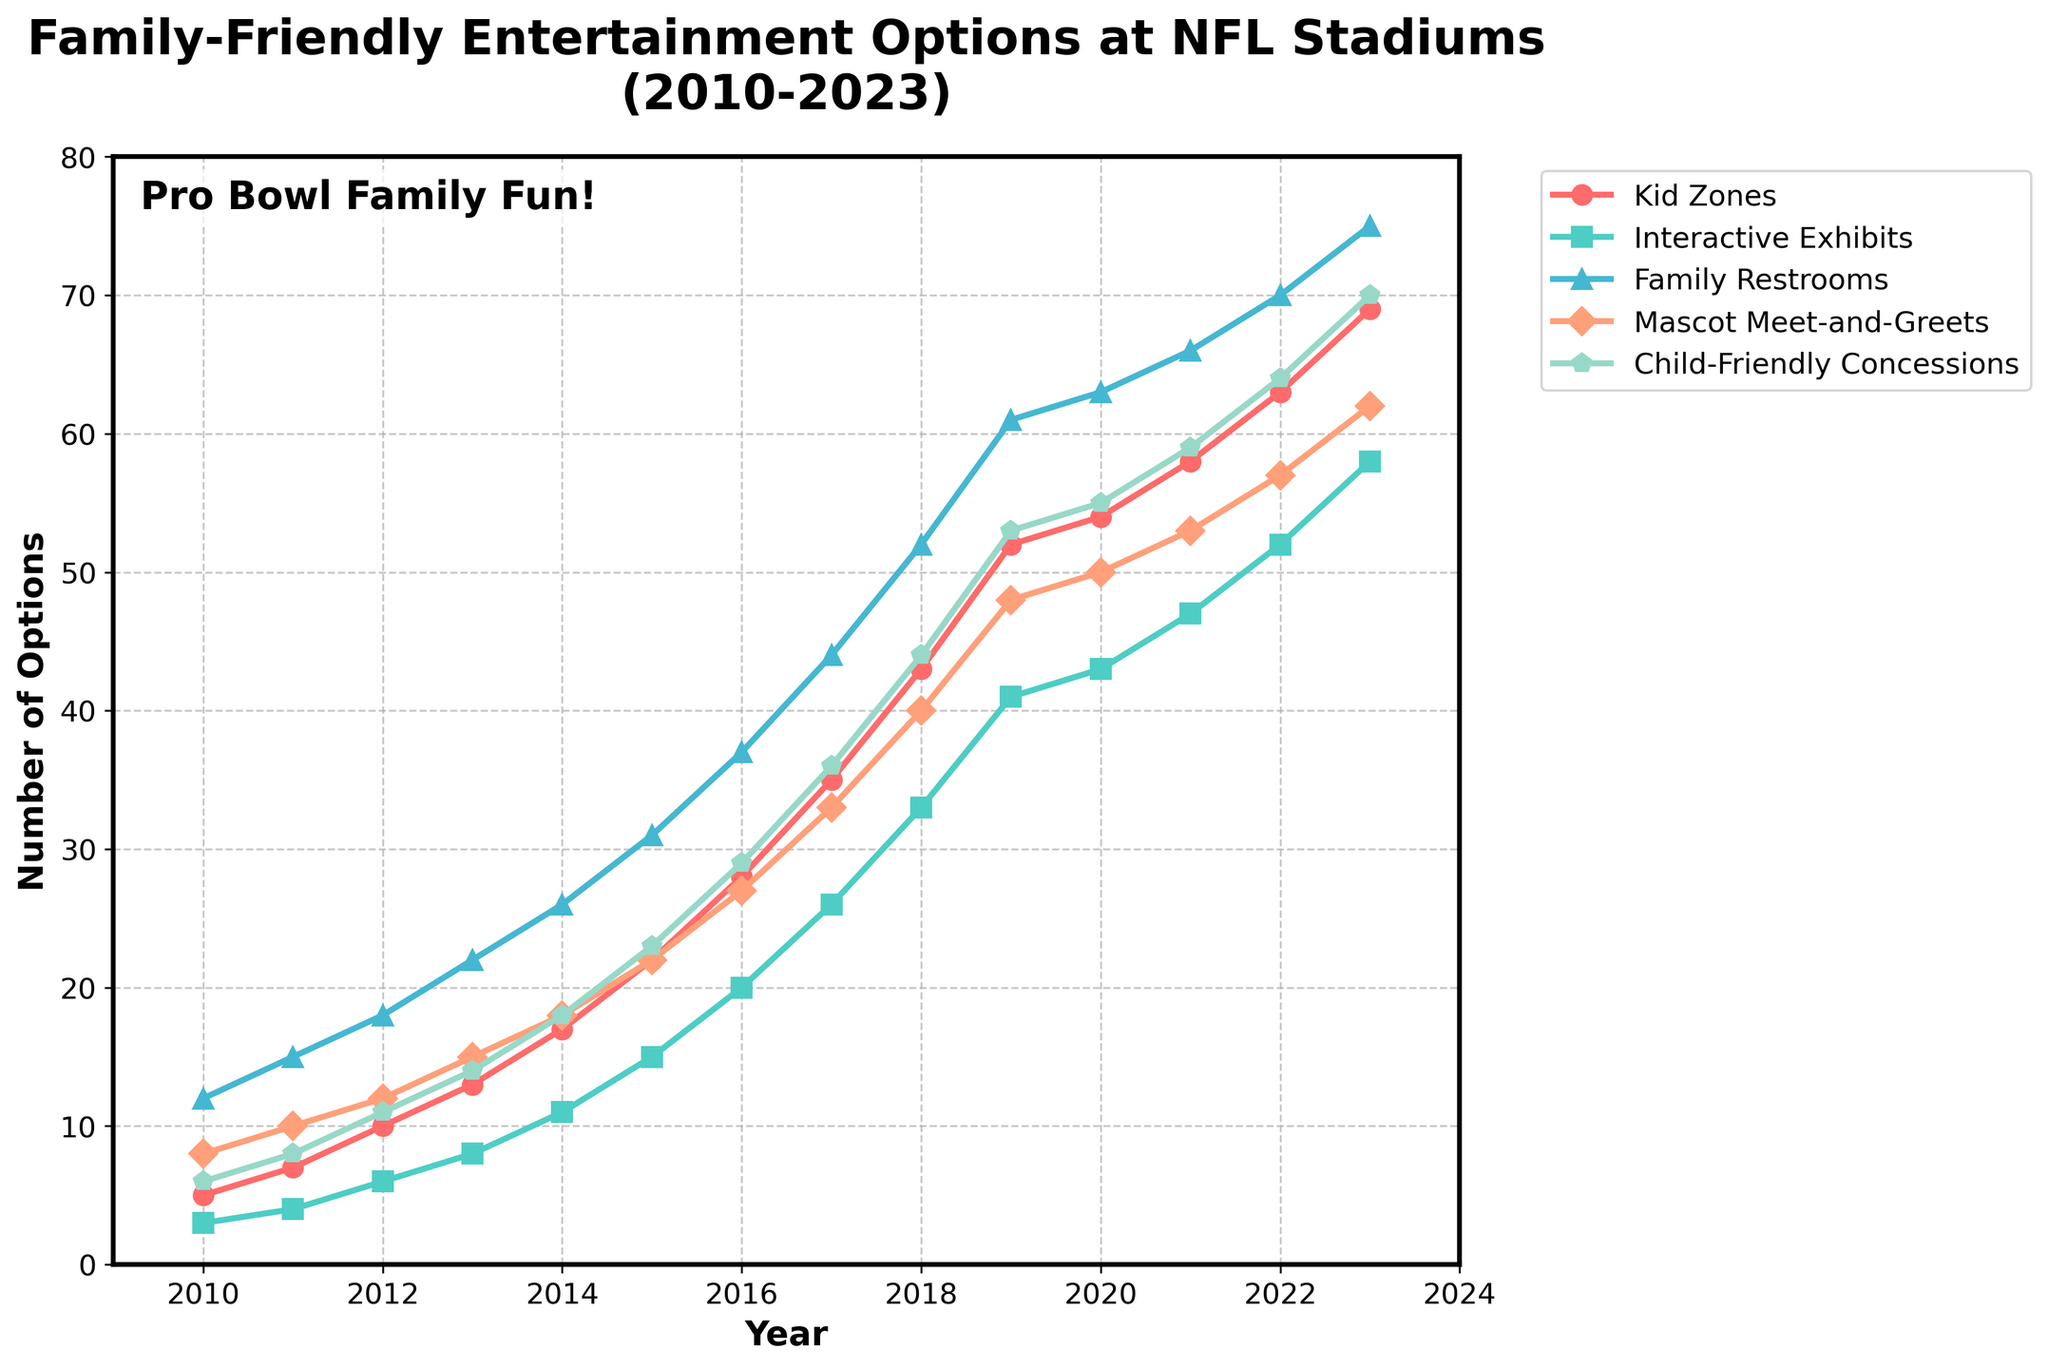What's the trend in the number of Kid Zones from 2010 to 2023? The number of Kid Zones increases each year from 5 in 2010 to 69 in 2023, showing a consistent upward trend.
Answer: Consistent upward Which year had the largest increase in Interactive Exhibits compared to the previous year? By comparing year-over-year increases, the largest increase is between 2017 and 2018, where the number jumped from 26 to 33, a change of 7.
Answer: 2017 to 2018 How does the number of Family Restrooms in 2015 compare to the number in 2023? The number of Family Restrooms in 2015 is 31, while in 2023 it is 75. To compare, there is an increase of 44 Family Restrooms from 2015 to 2023.
Answer: Increased by 44 What's the average number of Mascot Meet-and-Greets in the first five years depicted in the chart? The first five years are from 2010 to 2014. The numbers are 8, 10, 12, 15, and 18. Adding these gives 63, and the average is 63/5 = 12.6.
Answer: 12.6 What's the ratio of Kid Zones to Child-Friendly Concessions in 2023? In 2023, there are 69 Kid Zones and 70 Child-Friendly Concessions. The ratio is 69:70, which simplifies to approximately 0.99:1.
Answer: 0.99:1 How many more Kid Zones are there in 2023 compared to 2010? In 2010, there are 5 Kid Zones and in 2023, there are 69. The difference is 69 - 5 = 64.
Answer: 64 Which family-friendly option showed the smallest increase from 2010 to 2023? By checking the increases from 2010 to 2023 for all options: Kid Zones (64), Interactive Exhibits (55), Family Restrooms (63), Mascot Meet-and-Greets (54), Child-Friendly Concessions (64), Interactive Exhibits has the smallest increase.
Answer: Interactive Exhibits What year did Child-Friendly Concessions first exceed 50? According to the data, Child-Friendly Concessions first exceeded 50 in 2019, where the value is 53.
Answer: 2019 Compare the growth trend of Family Restrooms to that of Kid Zones. Both Family Restrooms and Kid Zones show an upward trend. The growth of Family Restrooms starts at 12 in 2010 and reaches 75 in 2023. Kid Zones start at 5 in 2010 and reach 69 in 2023, showing that Kid Zones have slightly less steep but consistent growth compared to Family Restrooms.
Answer: Upward for both What's the difference between the number of Interactive Exhibits and Child-Friendly Concessions in 2022? In 2022, there are 52 Interactive Exhibits and 64 Child-Friendly Concessions. The difference is 64 - 52 = 12.
Answer: 12 